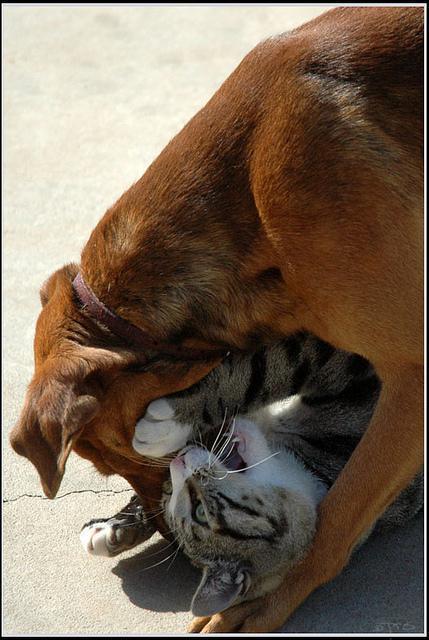How many of these animals have paws?
Give a very brief answer. 2. How many dogs are in the photo?
Give a very brief answer. 1. 